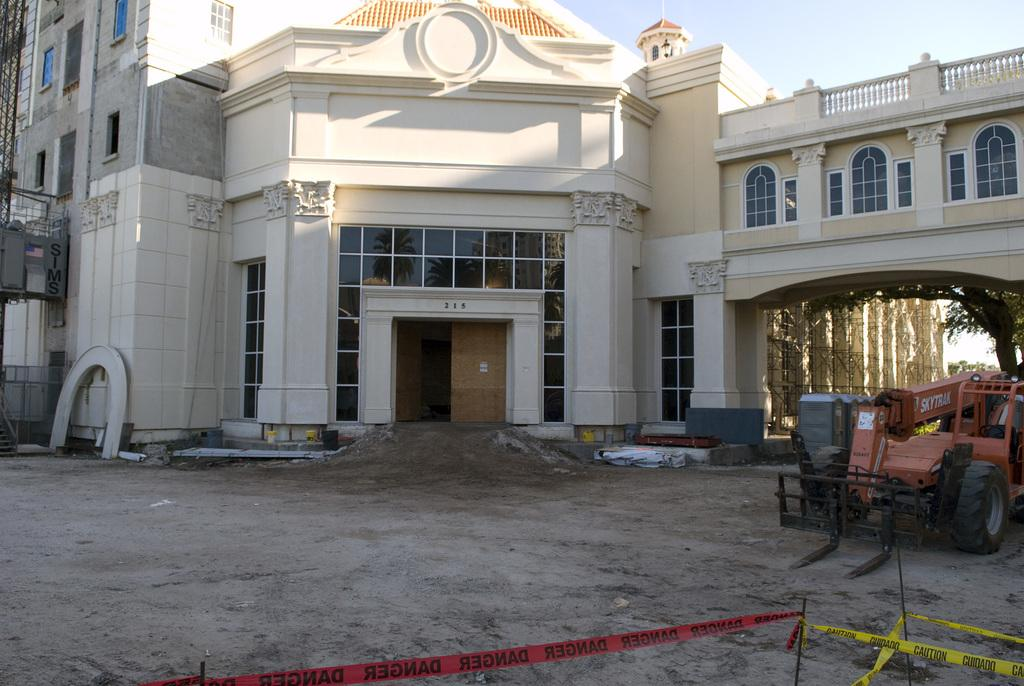What type of building is visible in the image? There is a building with glass windows in the image. What else can be seen in the image besides the building? There is a vehicle and a tree visible in the image. Is there a party happening inside the building in the image? There is no information about a party happening inside the building in the image. Can you see anyone wearing a hat in the image? There is no hat visible in the image. 